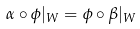Convert formula to latex. <formula><loc_0><loc_0><loc_500><loc_500>\alpha \circ \phi | _ { W } = \phi \circ \beta | _ { W }</formula> 